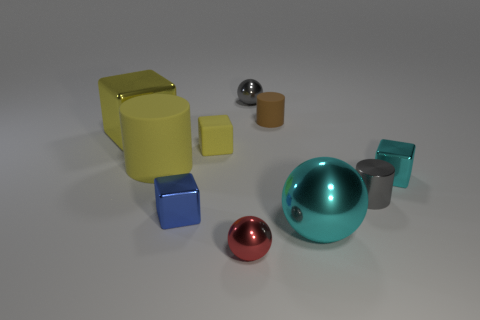Subtract 1 cubes. How many cubes are left? 3 Subtract all blocks. How many objects are left? 6 Add 5 blue shiny blocks. How many blue shiny blocks exist? 6 Subtract 1 yellow cylinders. How many objects are left? 9 Subtract all cyan things. Subtract all gray rubber cylinders. How many objects are left? 8 Add 3 small shiny balls. How many small shiny balls are left? 5 